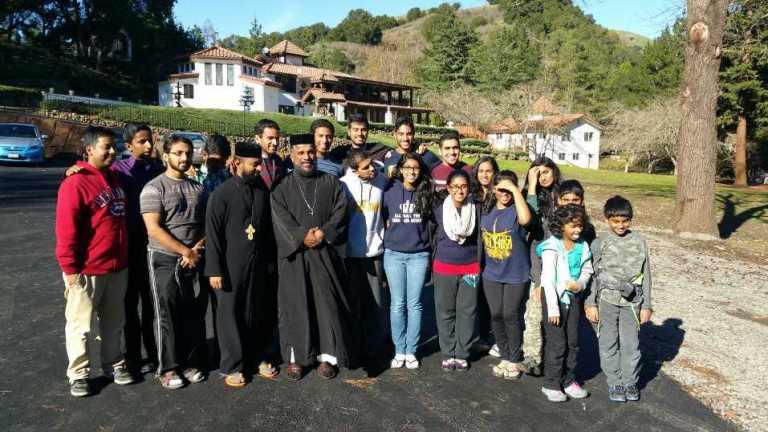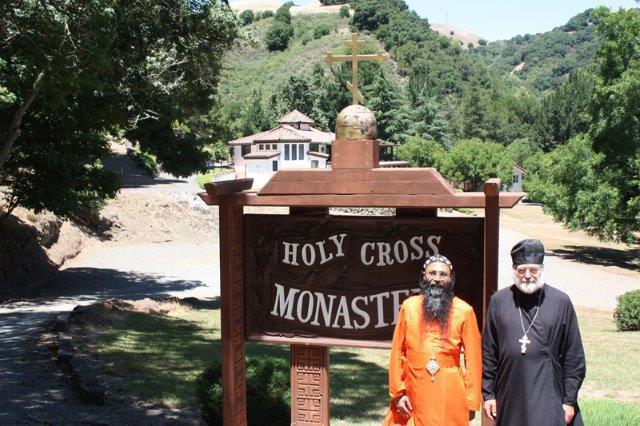The first image is the image on the left, the second image is the image on the right. Examine the images to the left and right. Is the description "The wooden sign is for a monastary." accurate? Answer yes or no. Yes. 